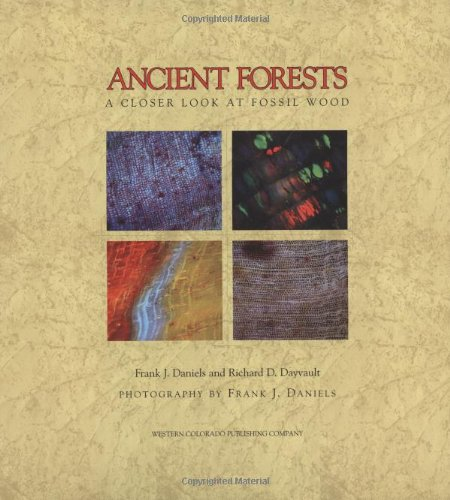Is this book related to Science & Math? Yes, 'Ancient Forests: A Closer Look at Fossil Wood' is deeply embedded in the Science & Math genre, offering insights into the geological processes that preserve organic materials and the ecological significance of these ancient landscapes. 